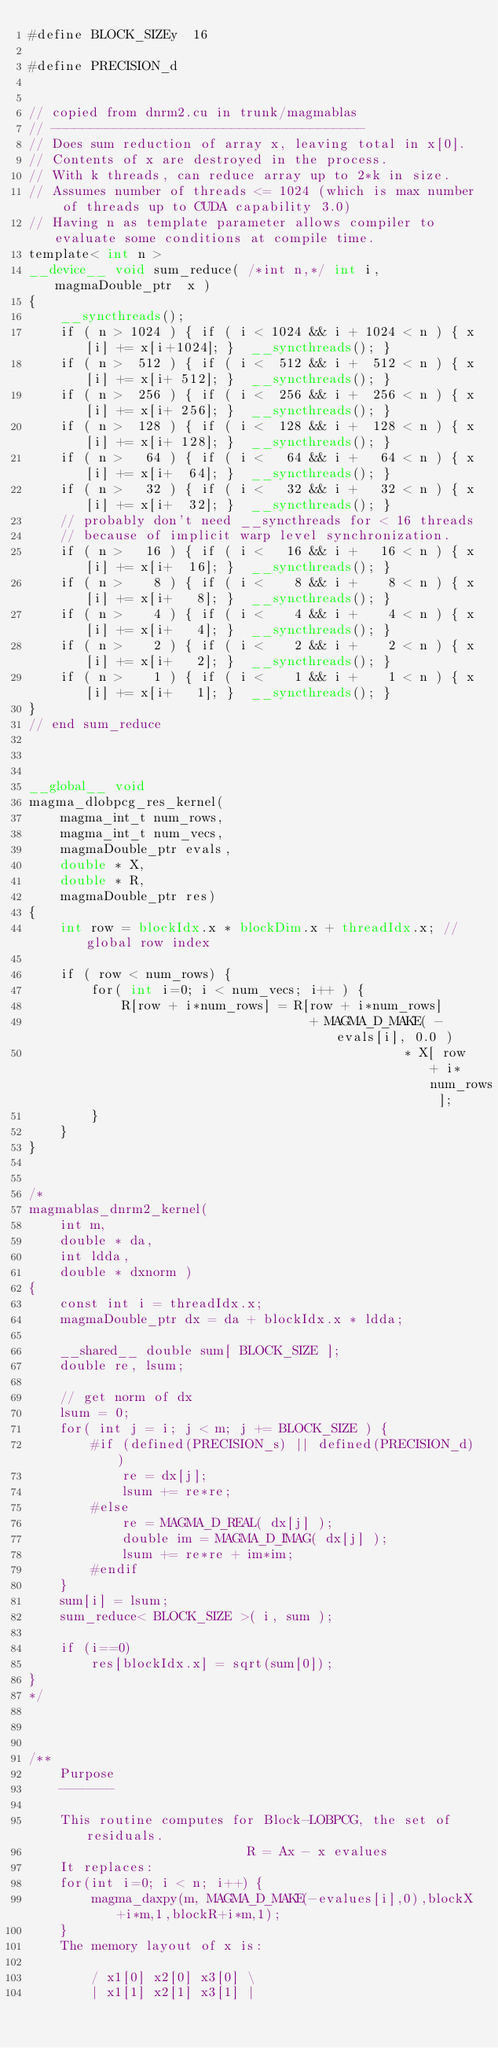<code> <loc_0><loc_0><loc_500><loc_500><_Cuda_>#define BLOCK_SIZEy  16

#define PRECISION_d


// copied from dnrm2.cu in trunk/magmablas
// ----------------------------------------
// Does sum reduction of array x, leaving total in x[0].
// Contents of x are destroyed in the process.
// With k threads, can reduce array up to 2*k in size.
// Assumes number of threads <= 1024 (which is max number of threads up to CUDA capability 3.0)
// Having n as template parameter allows compiler to evaluate some conditions at compile time.
template< int n >
__device__ void sum_reduce( /*int n,*/ int i, magmaDouble_ptr  x )
{
    __syncthreads();
    if ( n > 1024 ) { if ( i < 1024 && i + 1024 < n ) { x[i] += x[i+1024]; }  __syncthreads(); }
    if ( n >  512 ) { if ( i <  512 && i +  512 < n ) { x[i] += x[i+ 512]; }  __syncthreads(); }
    if ( n >  256 ) { if ( i <  256 && i +  256 < n ) { x[i] += x[i+ 256]; }  __syncthreads(); }
    if ( n >  128 ) { if ( i <  128 && i +  128 < n ) { x[i] += x[i+ 128]; }  __syncthreads(); }
    if ( n >   64 ) { if ( i <   64 && i +   64 < n ) { x[i] += x[i+  64]; }  __syncthreads(); }
    if ( n >   32 ) { if ( i <   32 && i +   32 < n ) { x[i] += x[i+  32]; }  __syncthreads(); }
    // probably don't need __syncthreads for < 16 threads
    // because of implicit warp level synchronization.
    if ( n >   16 ) { if ( i <   16 && i +   16 < n ) { x[i] += x[i+  16]; }  __syncthreads(); }
    if ( n >    8 ) { if ( i <    8 && i +    8 < n ) { x[i] += x[i+   8]; }  __syncthreads(); }
    if ( n >    4 ) { if ( i <    4 && i +    4 < n ) { x[i] += x[i+   4]; }  __syncthreads(); }
    if ( n >    2 ) { if ( i <    2 && i +    2 < n ) { x[i] += x[i+   2]; }  __syncthreads(); }
    if ( n >    1 ) { if ( i <    1 && i +    1 < n ) { x[i] += x[i+   1]; }  __syncthreads(); }
}
// end sum_reduce



__global__ void
magma_dlobpcg_res_kernel( 
    magma_int_t num_rows, 
    magma_int_t num_vecs, 
    magmaDouble_ptr evals, 
    double * X, 
    double * R,
    magmaDouble_ptr res)
{
    int row = blockIdx.x * blockDim.x + threadIdx.x; // global row index

    if ( row < num_rows) {
        for( int i=0; i < num_vecs; i++ ) {
            R[row + i*num_rows] = R[row + i*num_rows] 
                                    + MAGMA_D_MAKE( -evals[i], 0.0 )
                                                * X[ row + i*num_rows ];
        }
    }
}


/*
magmablas_dnrm2_kernel( 
    int m, 
    double * da, 
    int ldda, 
    double * dxnorm )
{
    const int i = threadIdx.x;
    magmaDouble_ptr dx = da + blockIdx.x * ldda;

    __shared__ double sum[ BLOCK_SIZE ];
    double re, lsum;

    // get norm of dx
    lsum = 0;
    for( int j = i; j < m; j += BLOCK_SIZE ) {
        #if (defined(PRECISION_s) || defined(PRECISION_d))
            re = dx[j];
            lsum += re*re;
        #else
            re = MAGMA_D_REAL( dx[j] );
            double im = MAGMA_D_IMAG( dx[j] );
            lsum += re*re + im*im;
        #endif
    }
    sum[i] = lsum;
    sum_reduce< BLOCK_SIZE >( i, sum );
    
    if (i==0)
        res[blockIdx.x] = sqrt(sum[0]);
}
*/



/**
    Purpose
    -------
    
    This routine computes for Block-LOBPCG, the set of residuals. 
                            R = Ax - x evalues
    It replaces:
    for(int i=0; i < n; i++) {
        magma_daxpy(m, MAGMA_D_MAKE(-evalues[i],0),blockX+i*m,1,blockR+i*m,1);
    }
    The memory layout of x is:

        / x1[0] x2[0] x3[0] \
        | x1[1] x2[1] x3[1] |</code> 